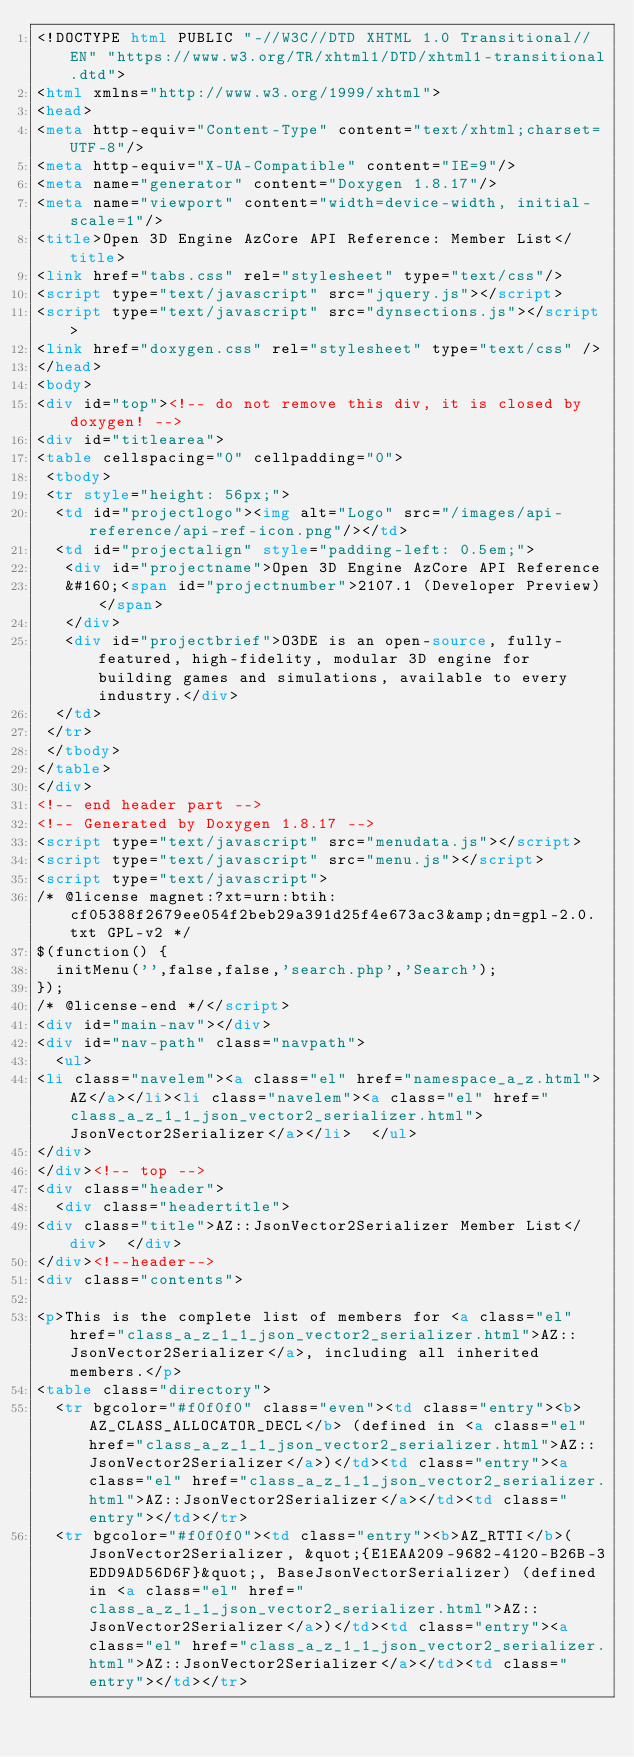<code> <loc_0><loc_0><loc_500><loc_500><_HTML_><!DOCTYPE html PUBLIC "-//W3C//DTD XHTML 1.0 Transitional//EN" "https://www.w3.org/TR/xhtml1/DTD/xhtml1-transitional.dtd">
<html xmlns="http://www.w3.org/1999/xhtml">
<head>
<meta http-equiv="Content-Type" content="text/xhtml;charset=UTF-8"/>
<meta http-equiv="X-UA-Compatible" content="IE=9"/>
<meta name="generator" content="Doxygen 1.8.17"/>
<meta name="viewport" content="width=device-width, initial-scale=1"/>
<title>Open 3D Engine AzCore API Reference: Member List</title>
<link href="tabs.css" rel="stylesheet" type="text/css"/>
<script type="text/javascript" src="jquery.js"></script>
<script type="text/javascript" src="dynsections.js"></script>
<link href="doxygen.css" rel="stylesheet" type="text/css" />
</head>
<body>
<div id="top"><!-- do not remove this div, it is closed by doxygen! -->
<div id="titlearea">
<table cellspacing="0" cellpadding="0">
 <tbody>
 <tr style="height: 56px;">
  <td id="projectlogo"><img alt="Logo" src="/images/api-reference/api-ref-icon.png"/></td>
  <td id="projectalign" style="padding-left: 0.5em;">
   <div id="projectname">Open 3D Engine AzCore API Reference
   &#160;<span id="projectnumber">2107.1 (Developer Preview)</span>
   </div>
   <div id="projectbrief">O3DE is an open-source, fully-featured, high-fidelity, modular 3D engine for building games and simulations, available to every industry.</div>
  </td>
 </tr>
 </tbody>
</table>
</div>
<!-- end header part -->
<!-- Generated by Doxygen 1.8.17 -->
<script type="text/javascript" src="menudata.js"></script>
<script type="text/javascript" src="menu.js"></script>
<script type="text/javascript">
/* @license magnet:?xt=urn:btih:cf05388f2679ee054f2beb29a391d25f4e673ac3&amp;dn=gpl-2.0.txt GPL-v2 */
$(function() {
  initMenu('',false,false,'search.php','Search');
});
/* @license-end */</script>
<div id="main-nav"></div>
<div id="nav-path" class="navpath">
  <ul>
<li class="navelem"><a class="el" href="namespace_a_z.html">AZ</a></li><li class="navelem"><a class="el" href="class_a_z_1_1_json_vector2_serializer.html">JsonVector2Serializer</a></li>  </ul>
</div>
</div><!-- top -->
<div class="header">
  <div class="headertitle">
<div class="title">AZ::JsonVector2Serializer Member List</div>  </div>
</div><!--header-->
<div class="contents">

<p>This is the complete list of members for <a class="el" href="class_a_z_1_1_json_vector2_serializer.html">AZ::JsonVector2Serializer</a>, including all inherited members.</p>
<table class="directory">
  <tr bgcolor="#f0f0f0" class="even"><td class="entry"><b>AZ_CLASS_ALLOCATOR_DECL</b> (defined in <a class="el" href="class_a_z_1_1_json_vector2_serializer.html">AZ::JsonVector2Serializer</a>)</td><td class="entry"><a class="el" href="class_a_z_1_1_json_vector2_serializer.html">AZ::JsonVector2Serializer</a></td><td class="entry"></td></tr>
  <tr bgcolor="#f0f0f0"><td class="entry"><b>AZ_RTTI</b>(JsonVector2Serializer, &quot;{E1EAA209-9682-4120-B26B-3EDD9AD56D6F}&quot;, BaseJsonVectorSerializer) (defined in <a class="el" href="class_a_z_1_1_json_vector2_serializer.html">AZ::JsonVector2Serializer</a>)</td><td class="entry"><a class="el" href="class_a_z_1_1_json_vector2_serializer.html">AZ::JsonVector2Serializer</a></td><td class="entry"></td></tr></code> 